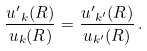<formula> <loc_0><loc_0><loc_500><loc_500>\frac { { u ^ { \prime } } _ { k } ( R ) } { u _ { k } ( R ) } = \frac { { u ^ { \prime } } _ { k ^ { \prime } } ( R ) } { u _ { k ^ { \prime } } ( R ) } \, .</formula> 